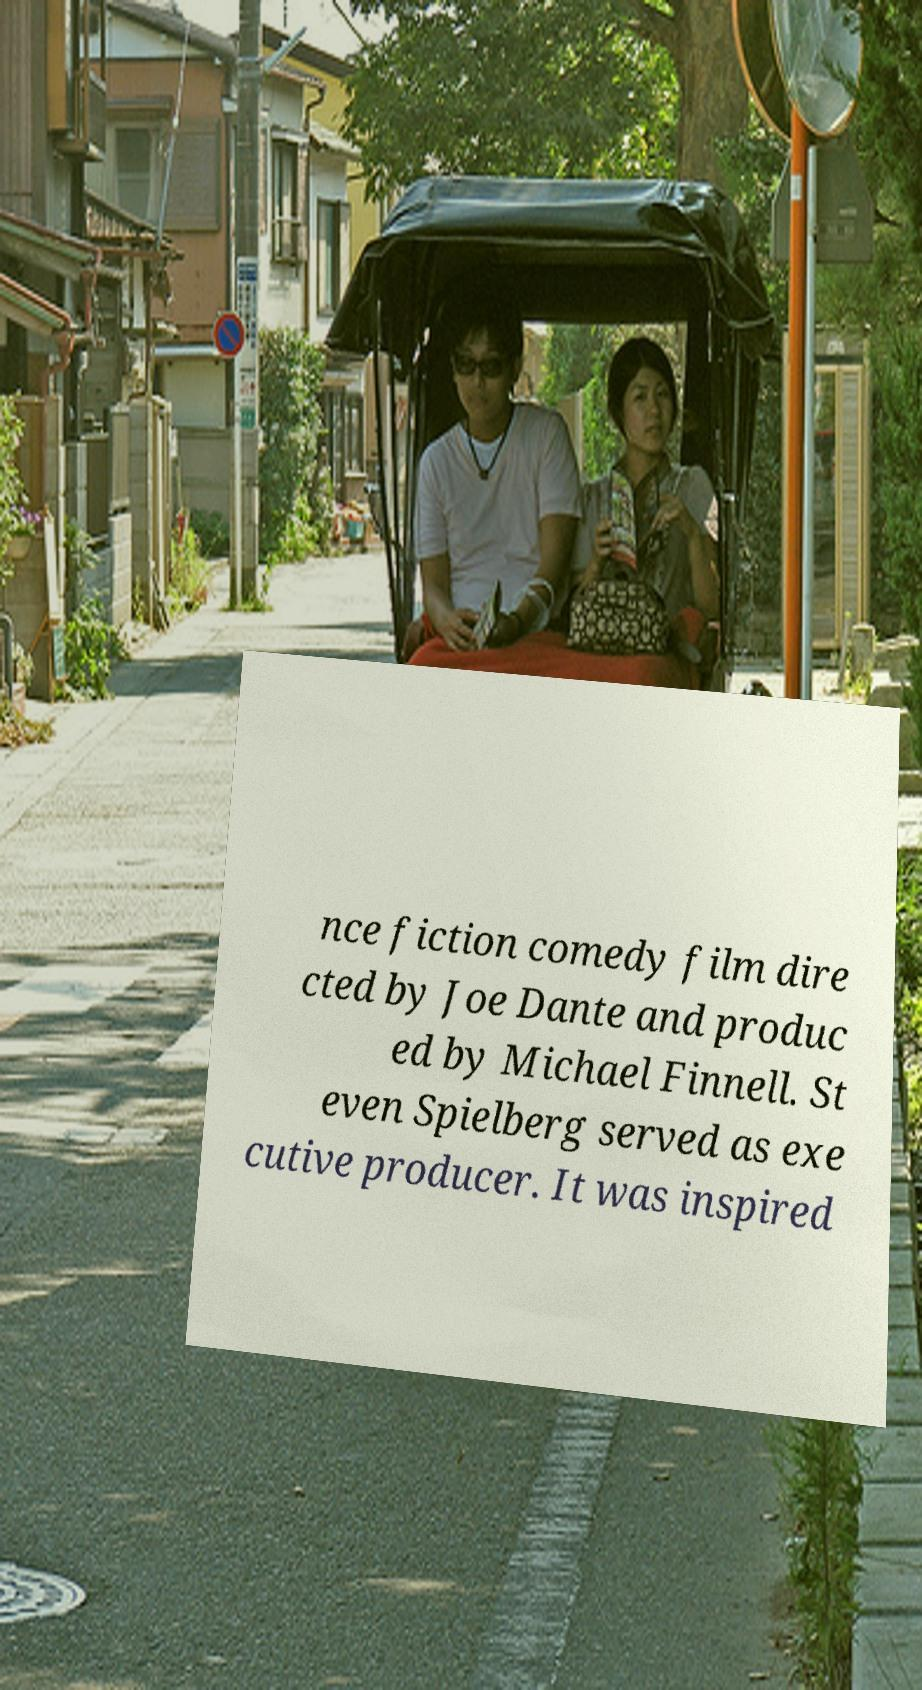Can you accurately transcribe the text from the provided image for me? nce fiction comedy film dire cted by Joe Dante and produc ed by Michael Finnell. St even Spielberg served as exe cutive producer. It was inspired 